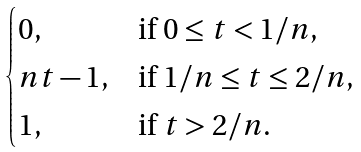Convert formula to latex. <formula><loc_0><loc_0><loc_500><loc_500>\begin{cases} 0 , & \text {if } 0 \leq t < 1 / n , \\ n t - 1 , & \text {if } 1 / n \leq t \leq 2 / n , \\ 1 , & \text {if } t > 2 / n . \end{cases}</formula> 